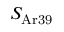<formula> <loc_0><loc_0><loc_500><loc_500>S _ { A r 3 9 }</formula> 